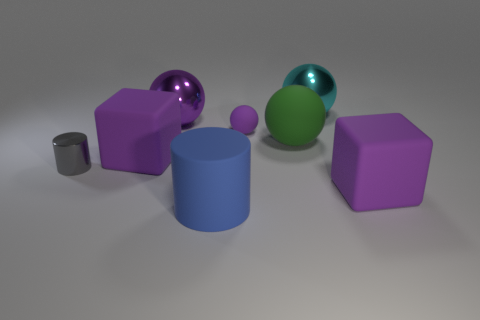The big metallic thing that is the same color as the small sphere is what shape?
Make the answer very short. Sphere. Is the number of purple objects behind the tiny sphere less than the number of purple cubes behind the small gray thing?
Offer a terse response. No. What number of other things are there of the same material as the green sphere
Make the answer very short. 4. Does the small cylinder have the same material as the large cyan object?
Offer a terse response. Yes. What number of other objects are there of the same size as the green sphere?
Ensure brevity in your answer.  5. There is a cyan thing that is behind the matte cube that is on the left side of the small purple sphere; what is its size?
Keep it short and to the point. Large. What is the color of the large rubber cube that is behind the big cube that is on the right side of the large metal object that is to the right of the tiny purple rubber object?
Keep it short and to the point. Purple. How big is the object that is both right of the blue cylinder and in front of the small metal object?
Provide a short and direct response. Large. What number of other things are the same shape as the green object?
Ensure brevity in your answer.  3. What number of balls are purple matte things or large blue things?
Offer a terse response. 1. 